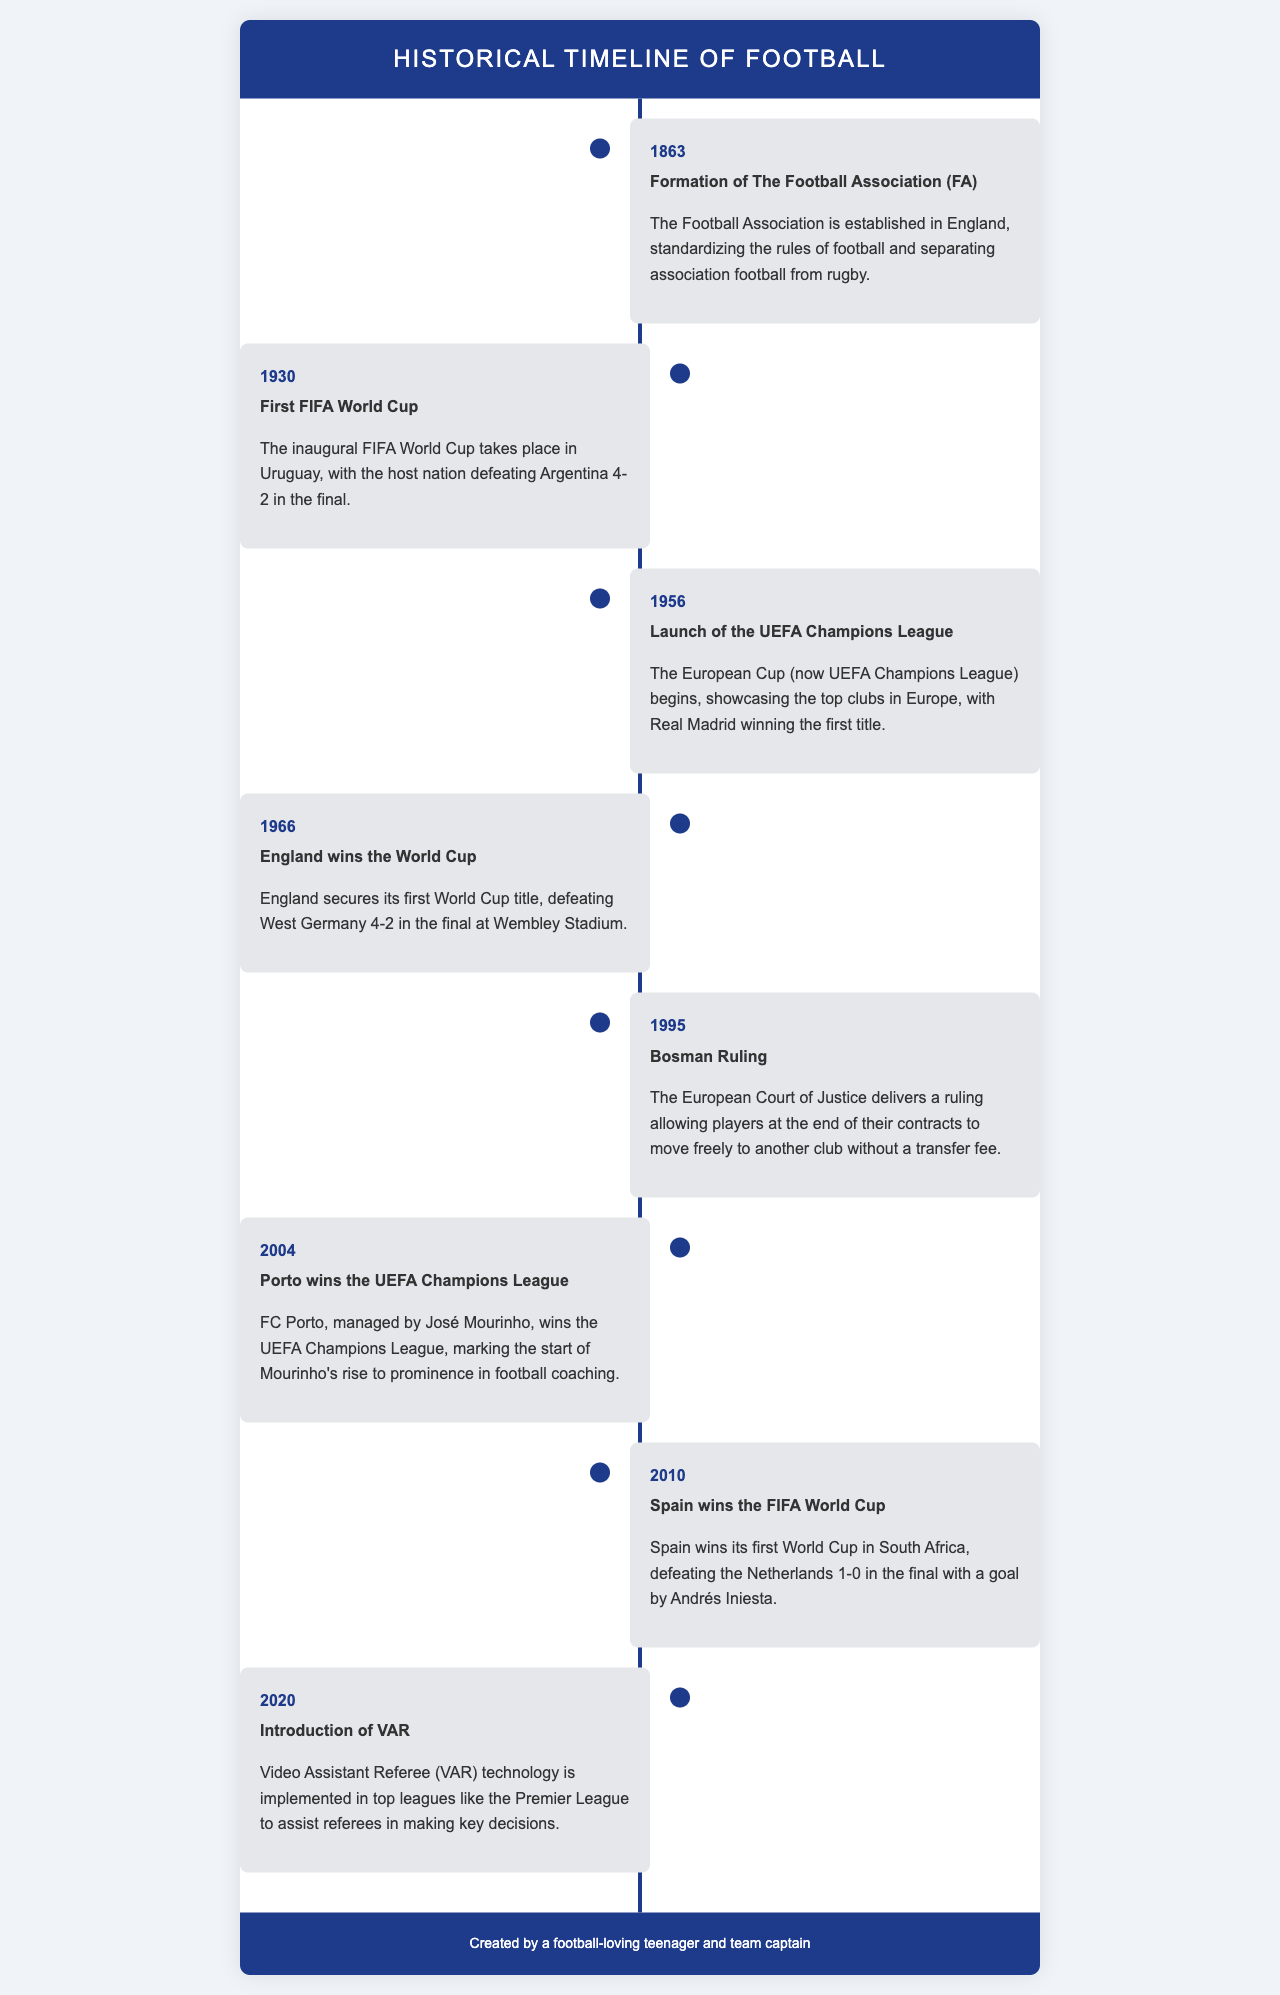What year was The Football Association formed? The document states that The Football Association was formed in 1863.
Answer: 1863 What significant event happened in 1966? The document highlights that in 1966, England won the World Cup.
Answer: England wins the World Cup Which team won the first UEFA Champions League title? The timeline mentions that Real Madrid won the first title of the UEFA Champions League in 1956.
Answer: Real Madrid What ruling allowed players to move freely at the end of their contracts? The document refers to the Bosman Ruling in 1995, which allowed this movement.
Answer: Bosman Ruling Who managed FC Porto when they won the UEFA Champions League in 2004? The document mentions José Mourinho as the manager of FC Porto at that time.
Answer: José Mourinho Which country won its first World Cup in 2010? According to the document, Spain won its first World Cup in 2010.
Answer: Spain What technological advancement was implemented in 2020? The document states that VAR (Video Assistant Referee) technology was introduced in 2020.
Answer: VAR What was the final score of the first FIFA World Cup final? The document specifies that the final score of the first FIFA World Cup final in 1930 was 4-2.
Answer: 4-2 In which stadium did England secure their 1966 World Cup victory? The document indicates that the final took place at Wembley Stadium.
Answer: Wembley Stadium 